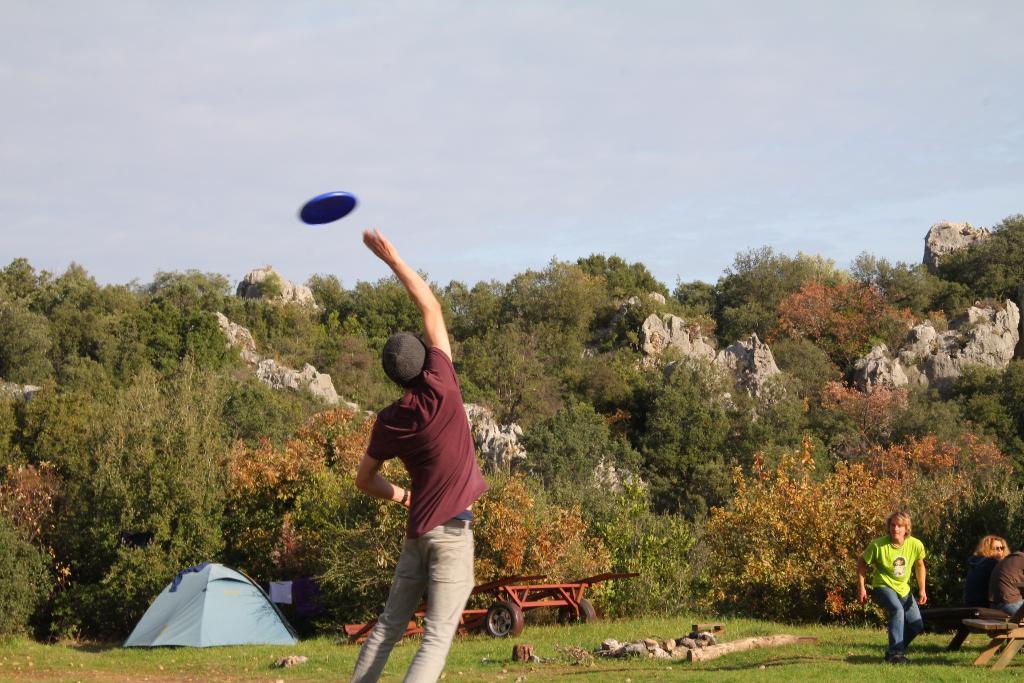How would you summarize this image in a sentence or two? In this picture we can see a person is trying to catch a disc in the front, on the right side there are three persons, we can see grass and stones at the bottom, in the background there are rocks, trees, a trolley and a tent, we can see the sky at the top of the picture. 